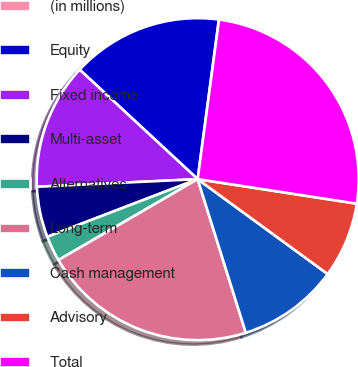Convert chart. <chart><loc_0><loc_0><loc_500><loc_500><pie_chart><fcel>(in millions)<fcel>Equity<fcel>Fixed income<fcel>Multi-asset<fcel>Alternatives<fcel>Long-term<fcel>Cash management<fcel>Advisory<fcel>Total<nl><fcel>0.02%<fcel>15.19%<fcel>12.66%<fcel>5.07%<fcel>2.55%<fcel>21.45%<fcel>10.13%<fcel>7.6%<fcel>25.31%<nl></chart> 